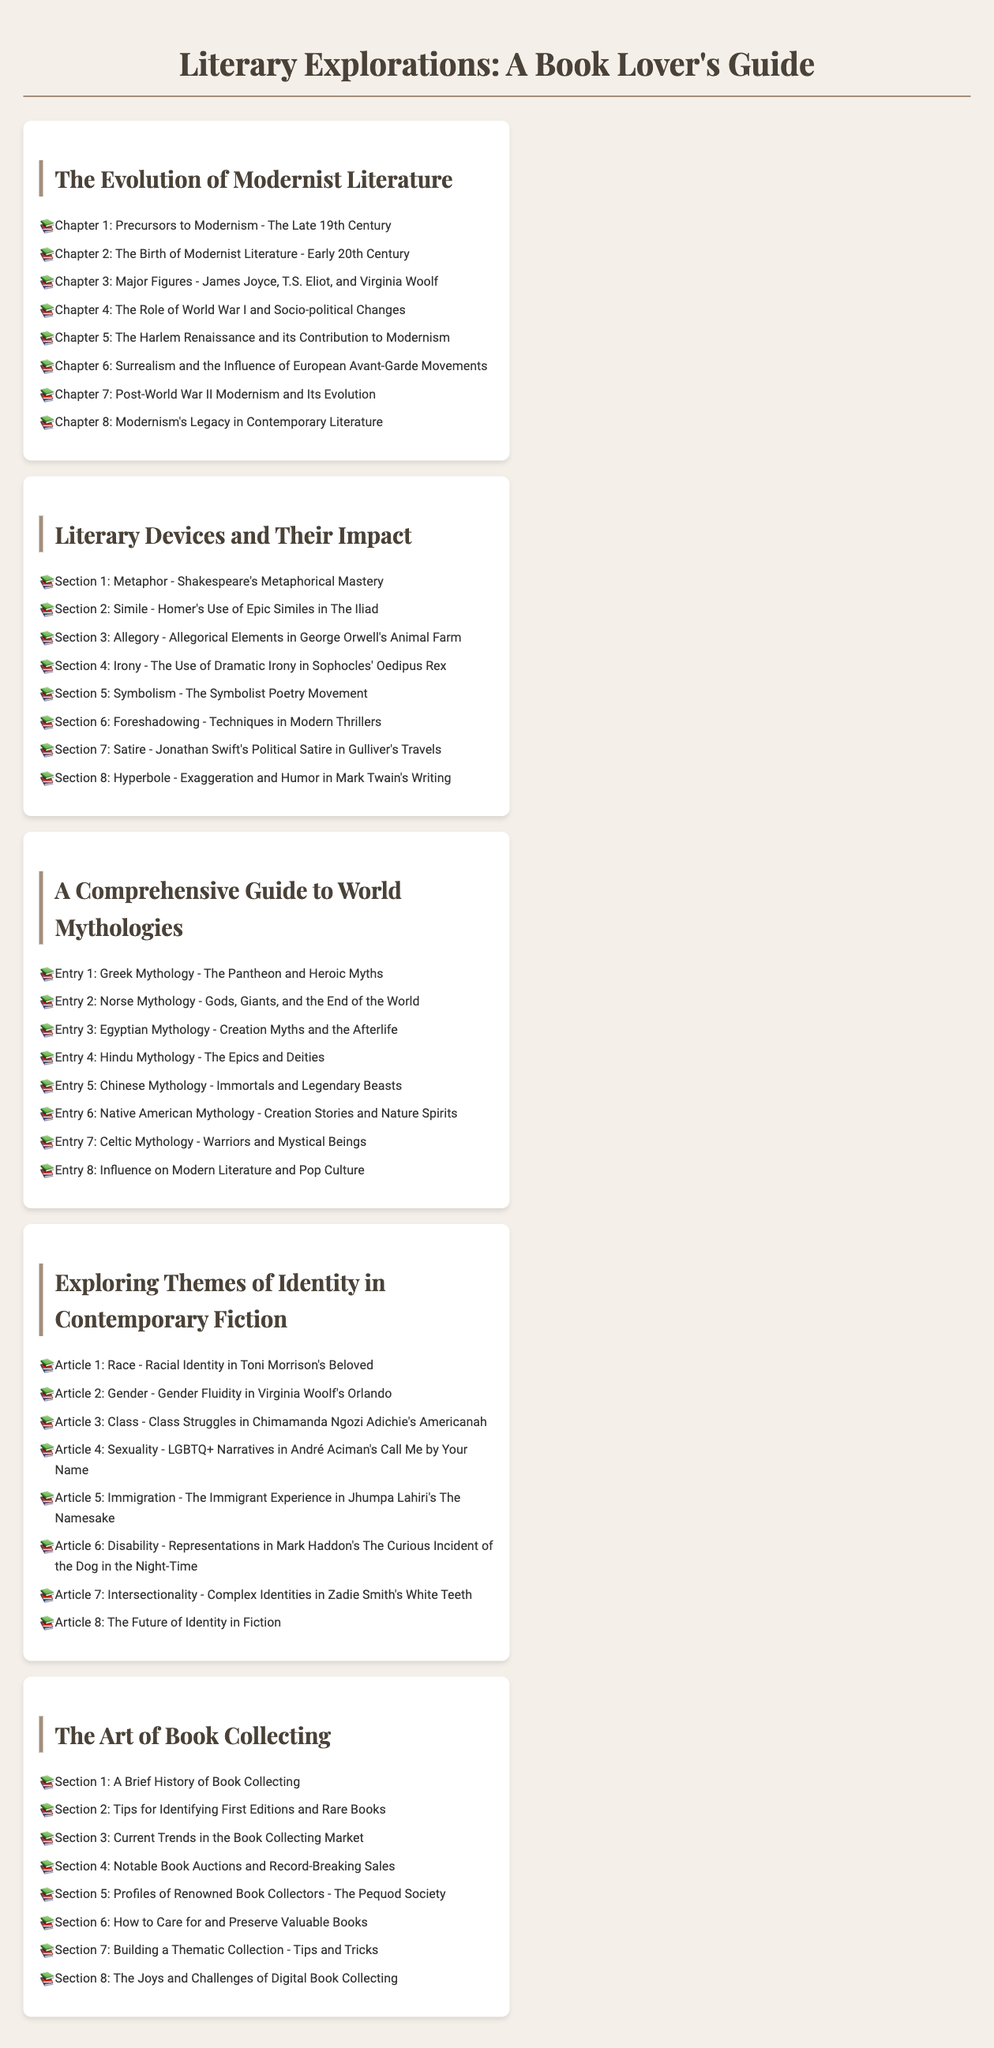What is the first chapter of Modernist Literature? The first chapter listed in the TOC is about the precursors to Modernism, specifically the late 19th century.
Answer: Precursors to Modernism - The Late 19th Century Who are the major figures in Modernist Literature? The TOC lists James Joyce, T.S. Eliot, and Virginia Woolf as major figures in Modernist Literature.
Answer: James Joyce, T.S. Eliot, and Virginia Woolf Which literary device is discussed in Section 4? Section 4 focuses on the use of dramatic irony in literature, specifically in Sophocles' Oedipus Rex.
Answer: Irony - The Use of Dramatic Irony in Sophocles' Oedipus Rex What theme is explored in Article 3 of contemporary fiction? Article 3 discusses class struggles as seen in Chimamanda Ngozi Adichie's Americanah.
Answer: Class - Class Struggles in Chimamanda Ngozi Adichie's Americanah How many entries are there in the guide to World Mythologies? There are eight entries listed in the guide to World Mythologies.
Answer: 8 What type of tips are provided in Section 2 of The Art of Book Collecting? Section 2 provides tips for identifying valuable editions and rare books.
Answer: Tips for Identifying First Editions and Rare Books What mythology is explored in Entry 1? Entry 1 focuses on Greek Mythology, including the pantheon and heroic myths.
Answer: Greek Mythology - The Pantheon and Heroic Myths Which article discusses disability in contemporary fiction? Article 6 addresses representations of disability in Mark Haddon's work.
Answer: Disability - Representations in Mark Haddon's The Curious Incident of the Dog in the Night-Time 